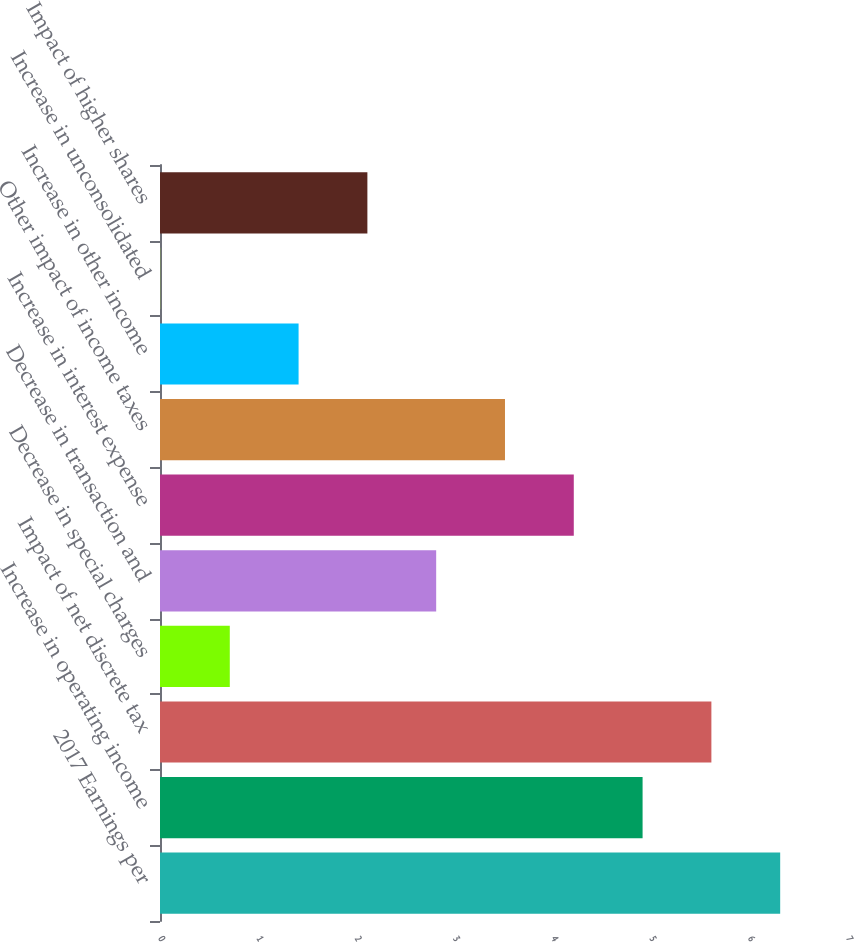Convert chart to OTSL. <chart><loc_0><loc_0><loc_500><loc_500><bar_chart><fcel>2017 Earnings per<fcel>Increase in operating income<fcel>Impact of net discrete tax<fcel>Decrease in special charges<fcel>Decrease in transaction and<fcel>Increase in interest expense<fcel>Other impact of income taxes<fcel>Increase in other income<fcel>Increase in unconsolidated<fcel>Impact of higher shares<nl><fcel>6.31<fcel>4.91<fcel>5.61<fcel>0.71<fcel>2.81<fcel>4.21<fcel>3.51<fcel>1.41<fcel>0.01<fcel>2.11<nl></chart> 